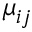Convert formula to latex. <formula><loc_0><loc_0><loc_500><loc_500>\mu _ { i j }</formula> 